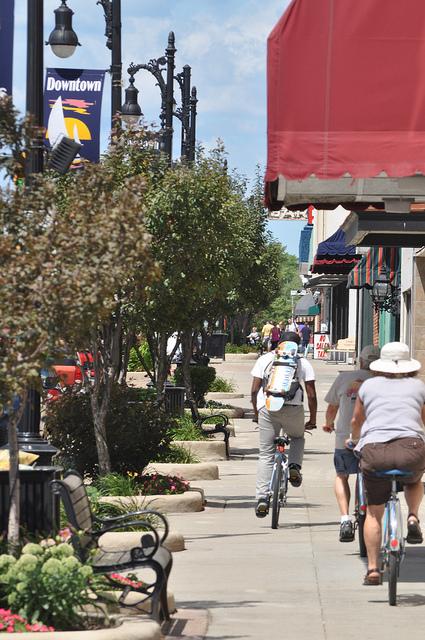Is the sidewalk the best place to ride bikes?
Answer briefly. No. Where is this?
Quick response, please. Downtown. Are the riding their bikes on a sidewalk?
Write a very short answer. Yes. 